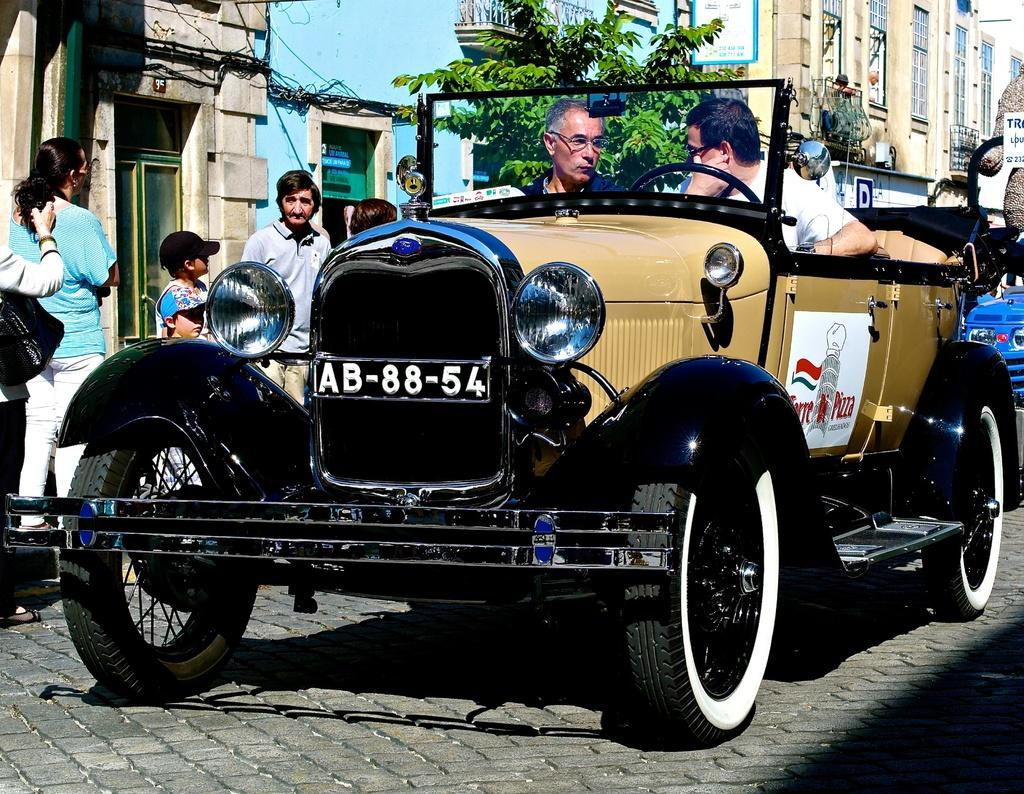What type of vehicle is in the image? There is a motor car in the image. Who is on the motor car? People are sitting on the motor car. What else can be seen in the image besides the motor car? There are people standing on the road, buildings, and trees in the background of the image. What type of steam is coming out of the motor car in the image? There is no steam coming out of the motor car in the image. Is there a zipper on the motor car in the image? There is no zipper present on the motor car in the image. 